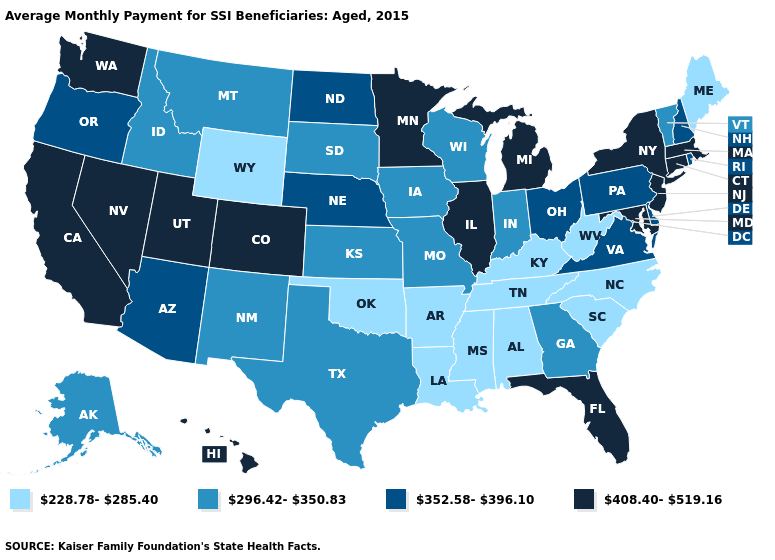Does Colorado have the highest value in the West?
Be succinct. Yes. Does Arizona have a higher value than Pennsylvania?
Give a very brief answer. No. Which states have the lowest value in the South?
Quick response, please. Alabama, Arkansas, Kentucky, Louisiana, Mississippi, North Carolina, Oklahoma, South Carolina, Tennessee, West Virginia. Which states have the lowest value in the Northeast?
Concise answer only. Maine. What is the value of Michigan?
Write a very short answer. 408.40-519.16. Is the legend a continuous bar?
Answer briefly. No. What is the highest value in the USA?
Keep it brief. 408.40-519.16. What is the value of Nevada?
Quick response, please. 408.40-519.16. Does Montana have the highest value in the West?
Concise answer only. No. Name the states that have a value in the range 408.40-519.16?
Concise answer only. California, Colorado, Connecticut, Florida, Hawaii, Illinois, Maryland, Massachusetts, Michigan, Minnesota, Nevada, New Jersey, New York, Utah, Washington. Among the states that border Texas , does New Mexico have the highest value?
Answer briefly. Yes. What is the value of Iowa?
Answer briefly. 296.42-350.83. Does Massachusetts have the highest value in the Northeast?
Write a very short answer. Yes. What is the value of Hawaii?
Short answer required. 408.40-519.16. What is the value of West Virginia?
Quick response, please. 228.78-285.40. 